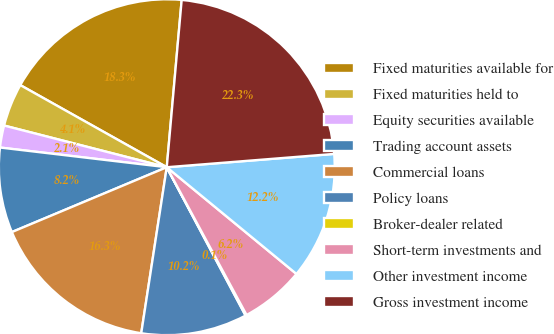Convert chart. <chart><loc_0><loc_0><loc_500><loc_500><pie_chart><fcel>Fixed maturities available for<fcel>Fixed maturities held to<fcel>Equity securities available<fcel>Trading account assets<fcel>Commercial loans<fcel>Policy loans<fcel>Broker-dealer related<fcel>Short-term investments and<fcel>Other investment income<fcel>Gross investment income<nl><fcel>18.28%<fcel>4.14%<fcel>2.12%<fcel>8.18%<fcel>16.26%<fcel>10.2%<fcel>0.11%<fcel>6.16%<fcel>12.22%<fcel>22.32%<nl></chart> 